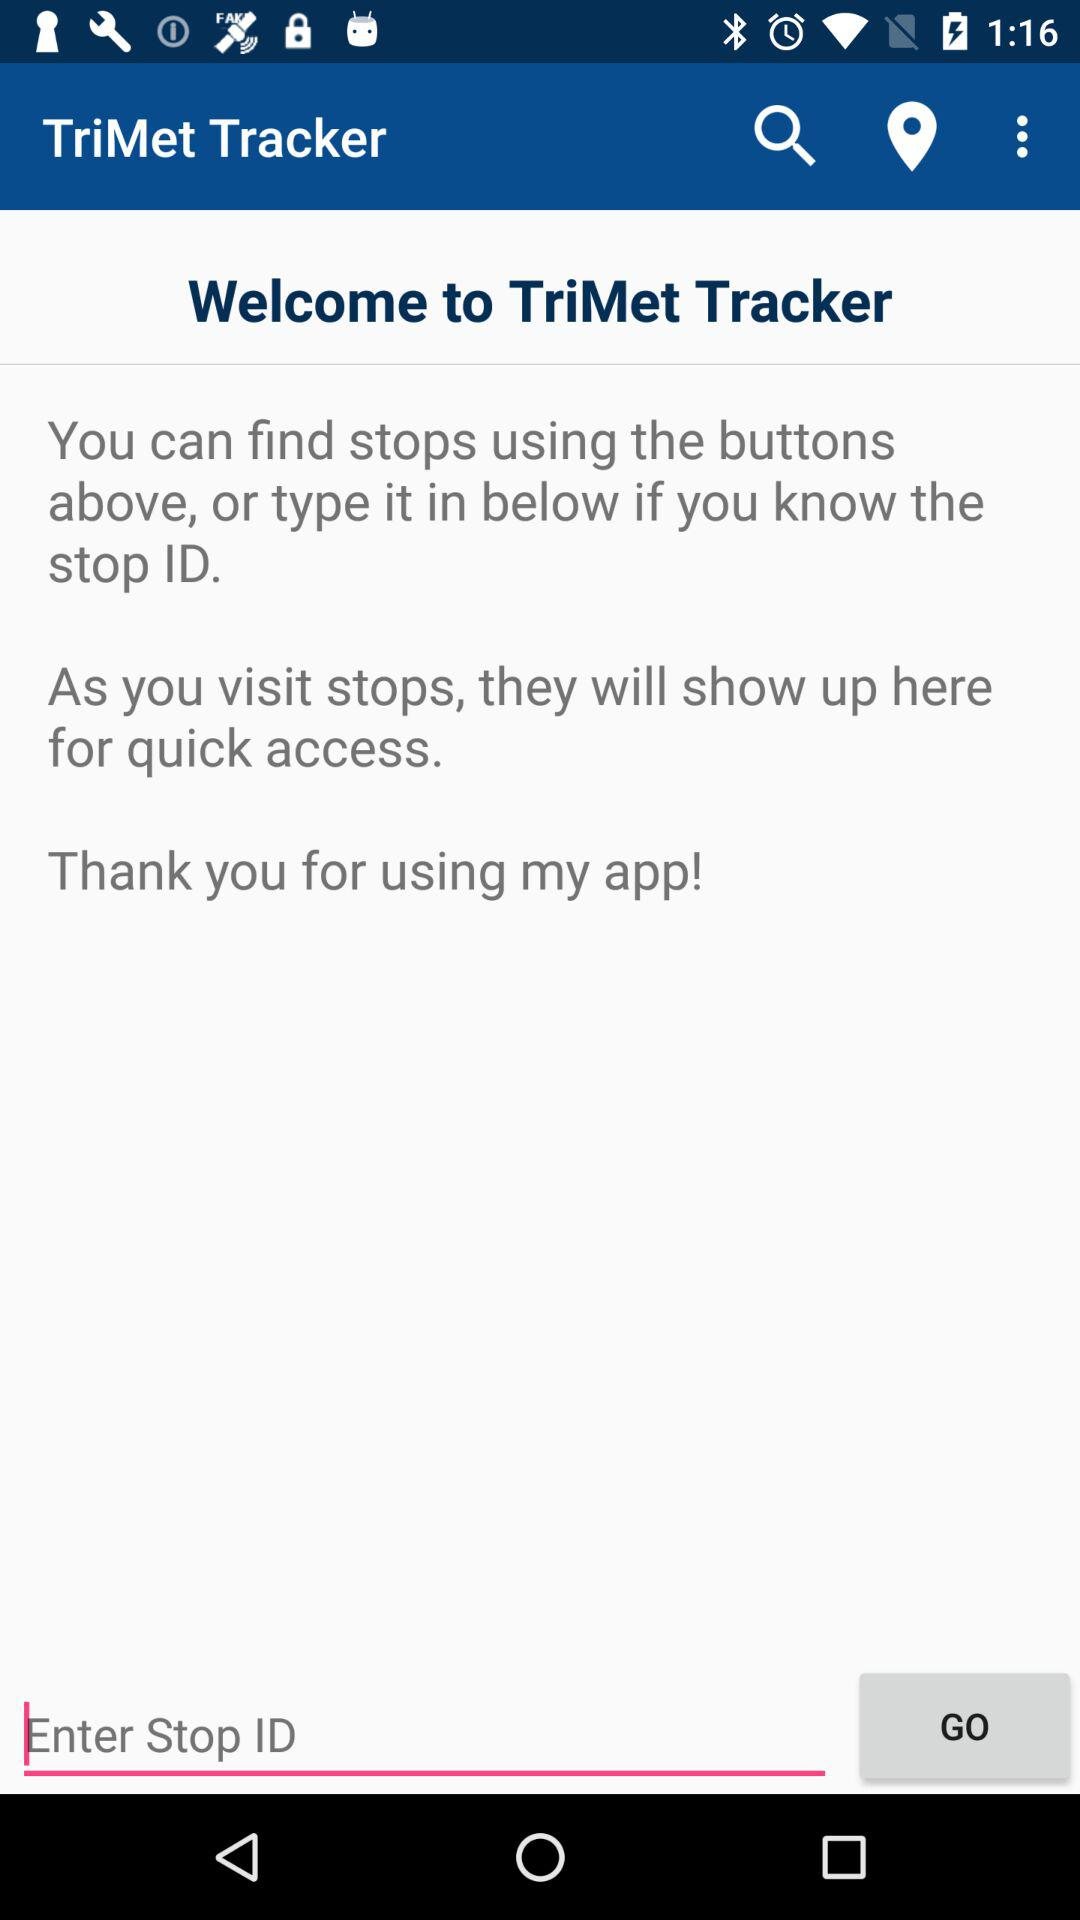What is the name of the application? The name of the application is "TriMet Tracker". 